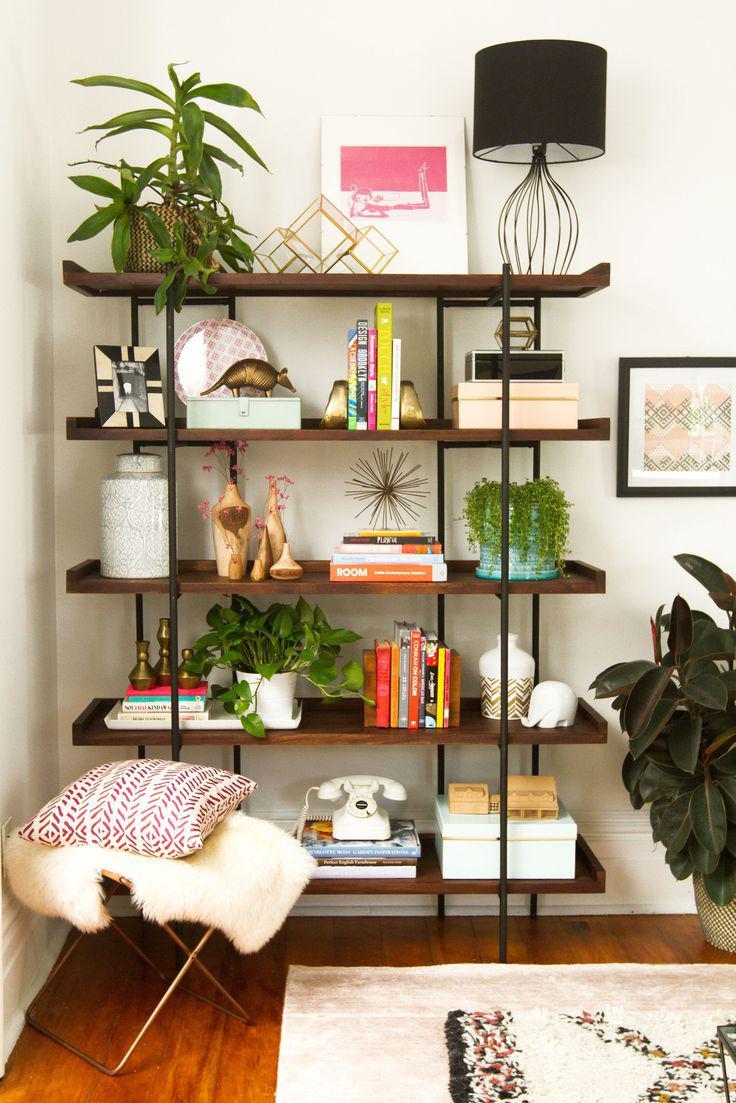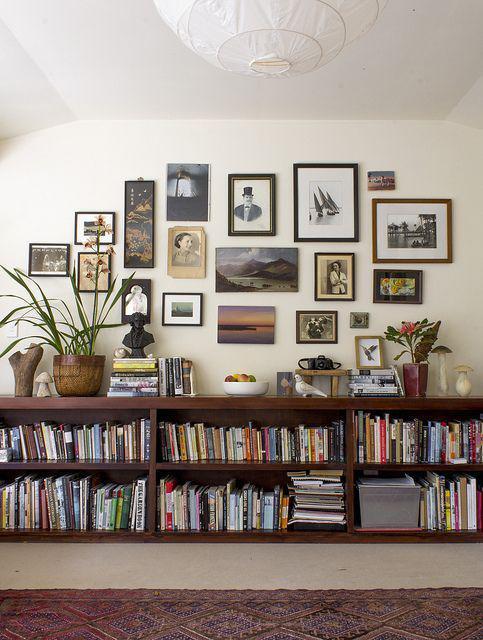The first image is the image on the left, the second image is the image on the right. Analyze the images presented: Is the assertion "A ceiling lamp that hangs over a room is glass-like." valid? Answer yes or no. No. The first image is the image on the left, the second image is the image on the right. Assess this claim about the two images: "A green plant with fanning leaves is near a backless and sideless set of vertical shelves.". Correct or not? Answer yes or no. Yes. 